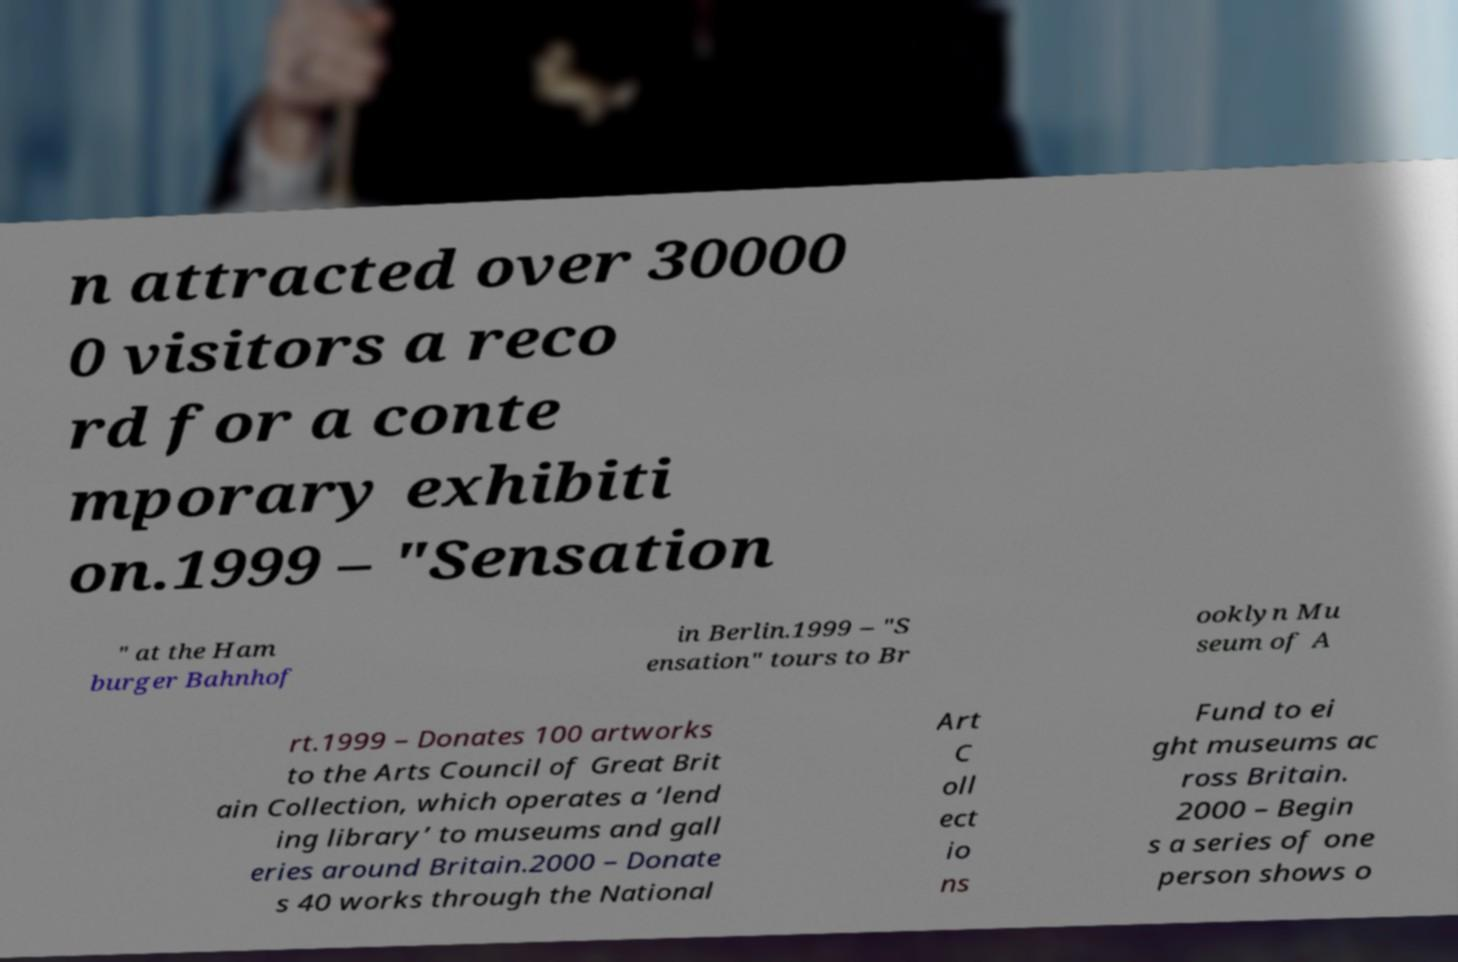Could you assist in decoding the text presented in this image and type it out clearly? n attracted over 30000 0 visitors a reco rd for a conte mporary exhibiti on.1999 – "Sensation " at the Ham burger Bahnhof in Berlin.1999 – "S ensation" tours to Br ooklyn Mu seum of A rt.1999 – Donates 100 artworks to the Arts Council of Great Brit ain Collection, which operates a ‘lend ing library’ to museums and gall eries around Britain.2000 – Donate s 40 works through the National Art C oll ect io ns Fund to ei ght museums ac ross Britain. 2000 – Begin s a series of one person shows o 